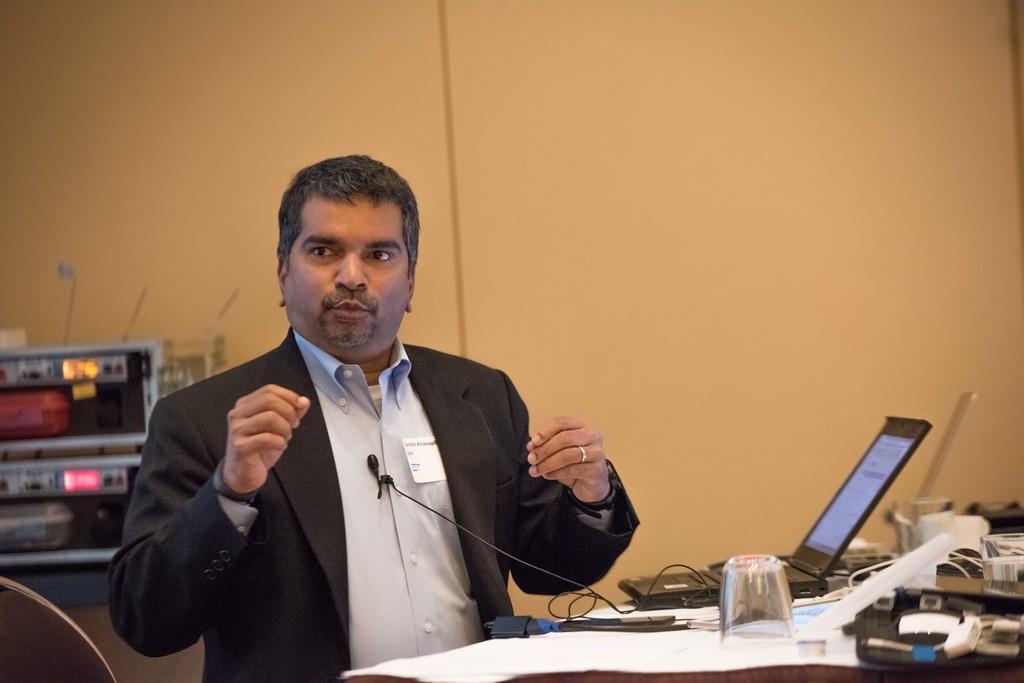In one or two sentences, can you explain what this image depicts? Here in this picture we can see a person wearing a black colored coat, standing over a place and speaking something and we can see a microphone present on his shirt and in front of him we can see a table, on which we can see number of papers, laptop, glass and other things present and behind him we can see some electronic equipment present on a table. 